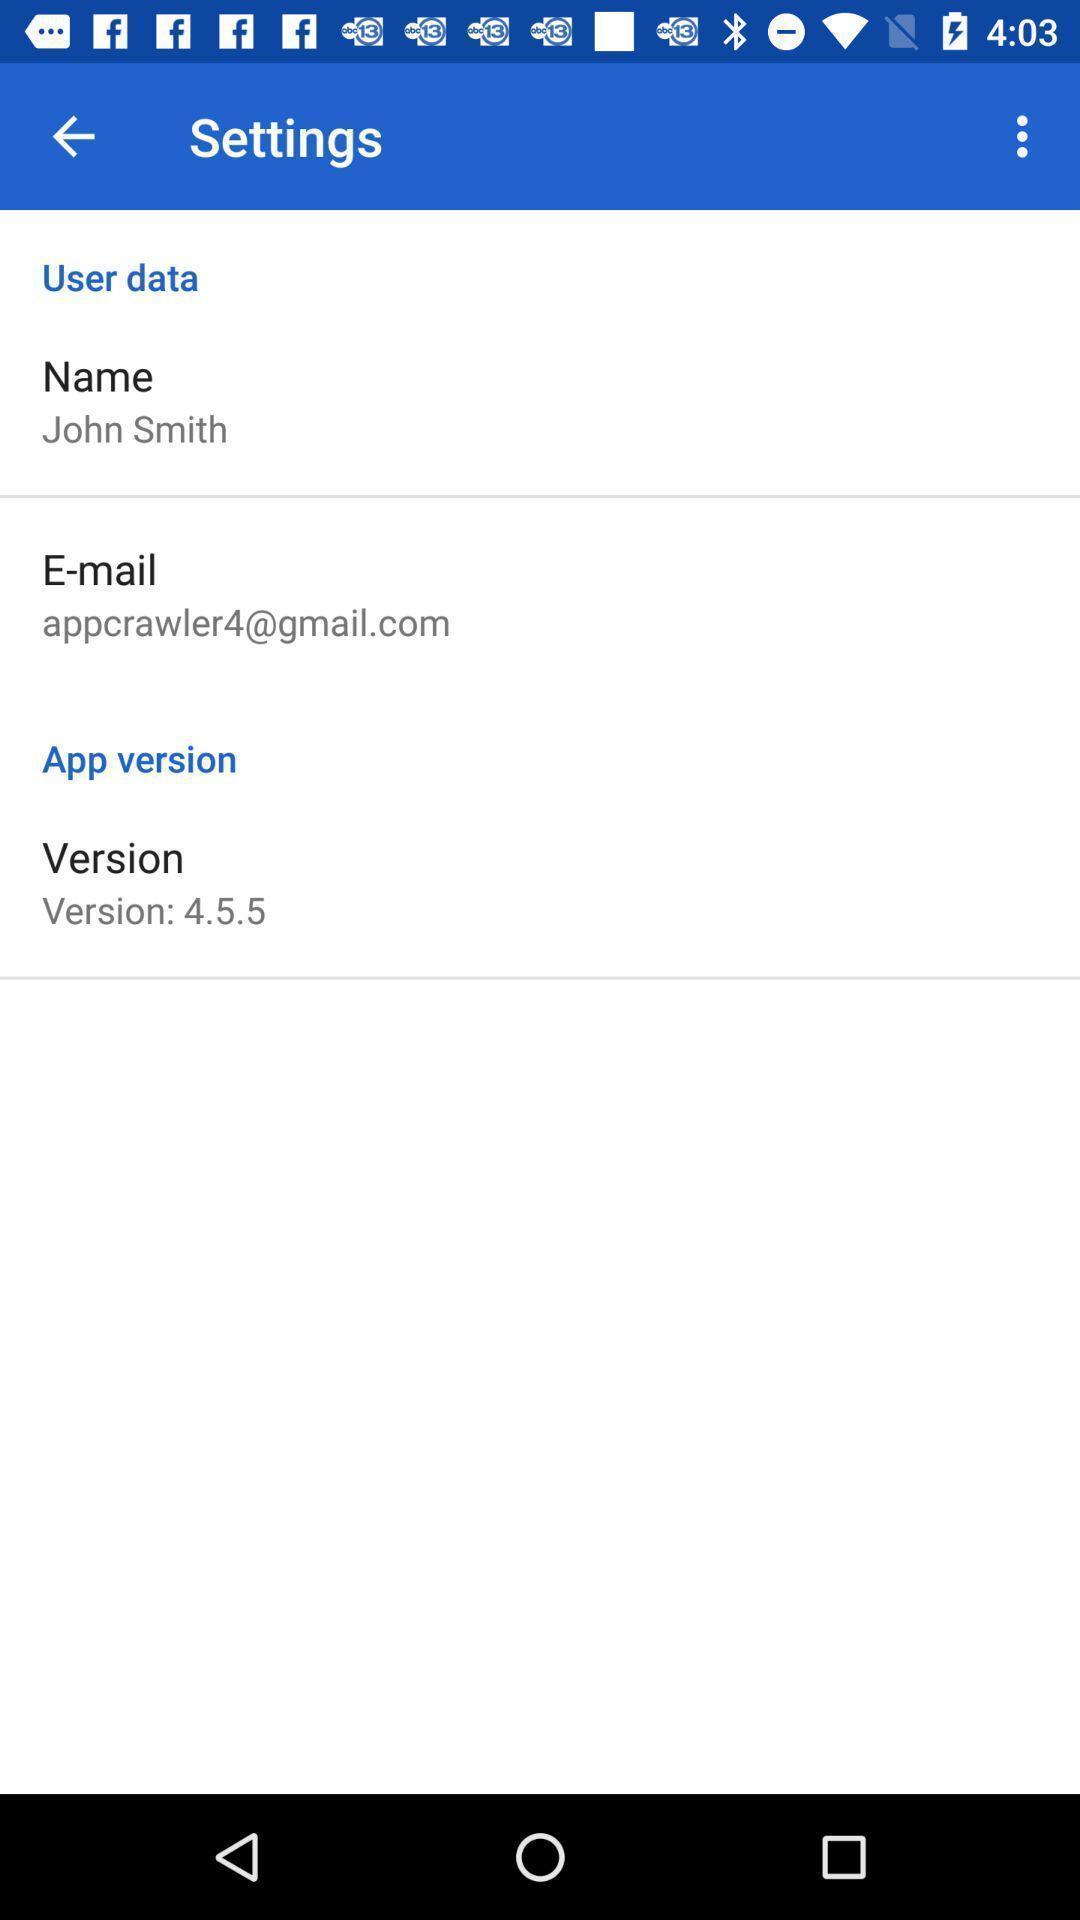Give me a narrative description of this picture. Setting page displaying the various options. 